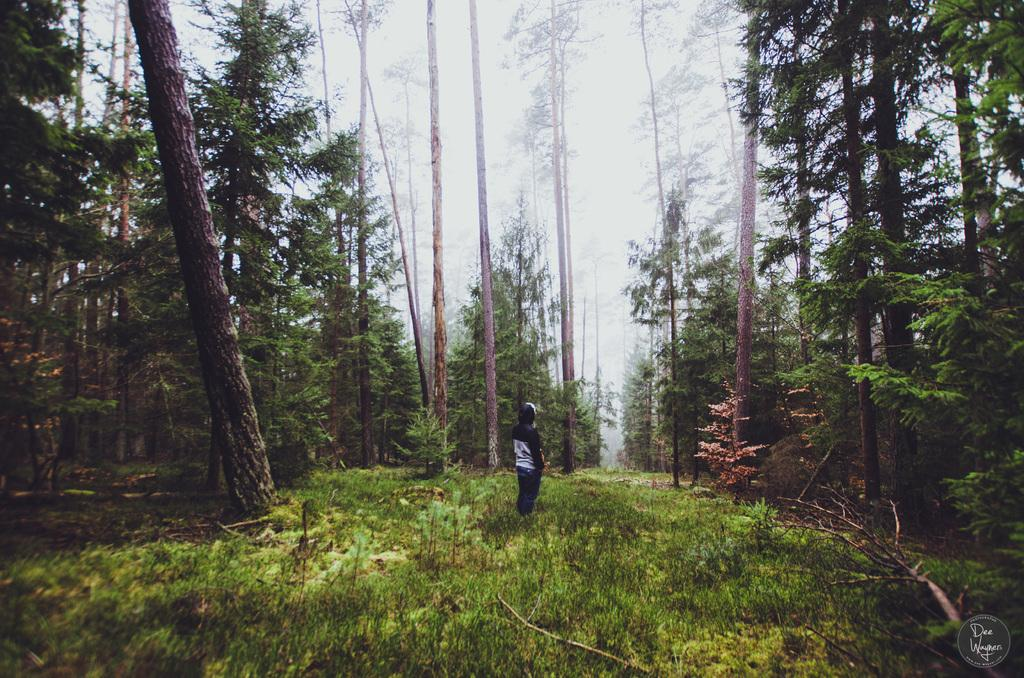What is the primary subject in the image? There is a person standing in the image. Can you describe the person's position? The person is in front. What type of natural environment is visible in the image? There is grass visible in the image. What can be seen in the background of the image? There are trees in the background of the image. Is there any additional information about the image itself? Yes, there is a watermark on the right bottom of the image. What type of humor can be seen in the image? There is no humor present in the image; it features a person standing in front of grass and trees. Can you see any ghosts in the image? There are no ghosts present in the image; it features a person standing in front of grass and trees. 